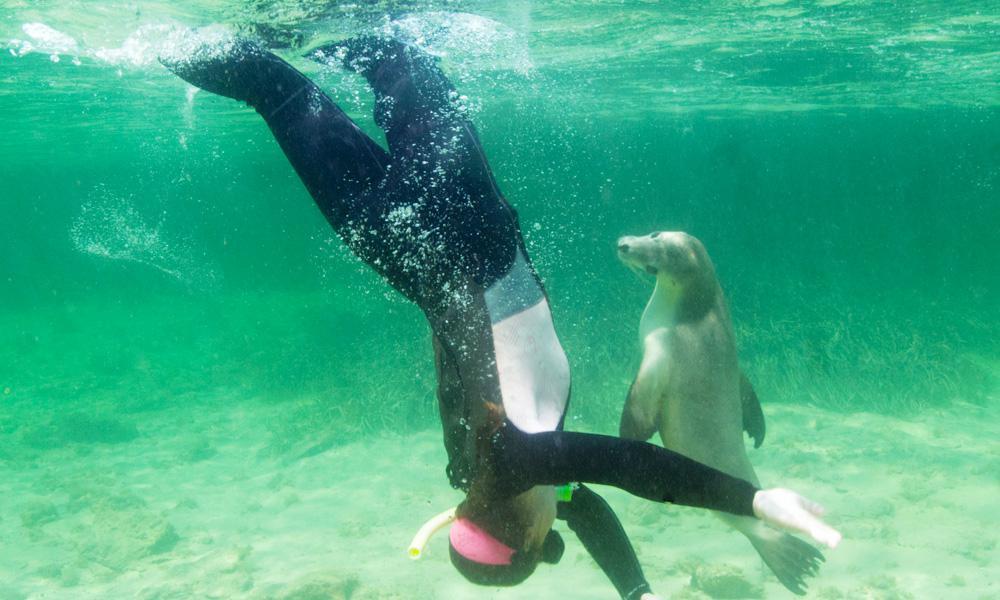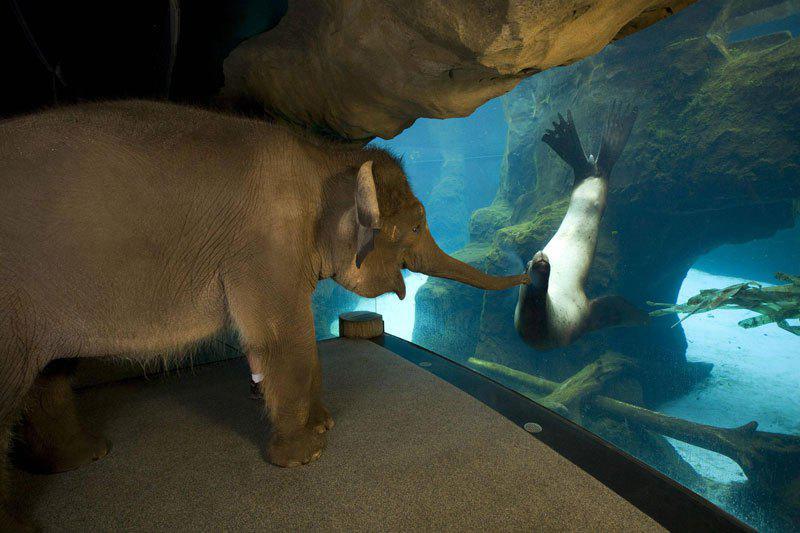The first image is the image on the left, the second image is the image on the right. For the images displayed, is the sentence "The left image shows a diver in a wetsuit interacting with a seal, but the right image does not include a diver." factually correct? Answer yes or no. Yes. The first image is the image on the left, the second image is the image on the right. For the images shown, is this caption "In at least one image there is a sea lion swimming alone with no other mammals present." true? Answer yes or no. No. 